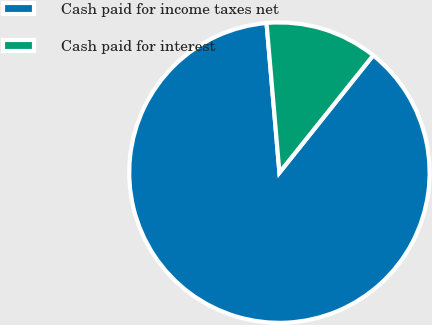<chart> <loc_0><loc_0><loc_500><loc_500><pie_chart><fcel>Cash paid for income taxes net<fcel>Cash paid for interest<nl><fcel>87.9%<fcel>12.1%<nl></chart> 